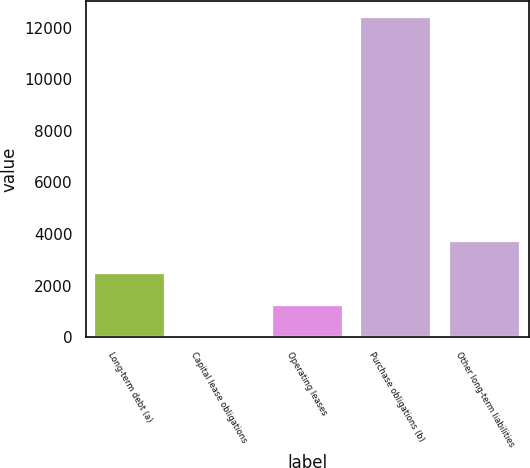<chart> <loc_0><loc_0><loc_500><loc_500><bar_chart><fcel>Long-term debt (a)<fcel>Capital lease obligations<fcel>Operating leases<fcel>Purchase obligations (b)<fcel>Other long-term liabilities<nl><fcel>2481.8<fcel>2<fcel>1241.9<fcel>12401<fcel>3721.7<nl></chart> 